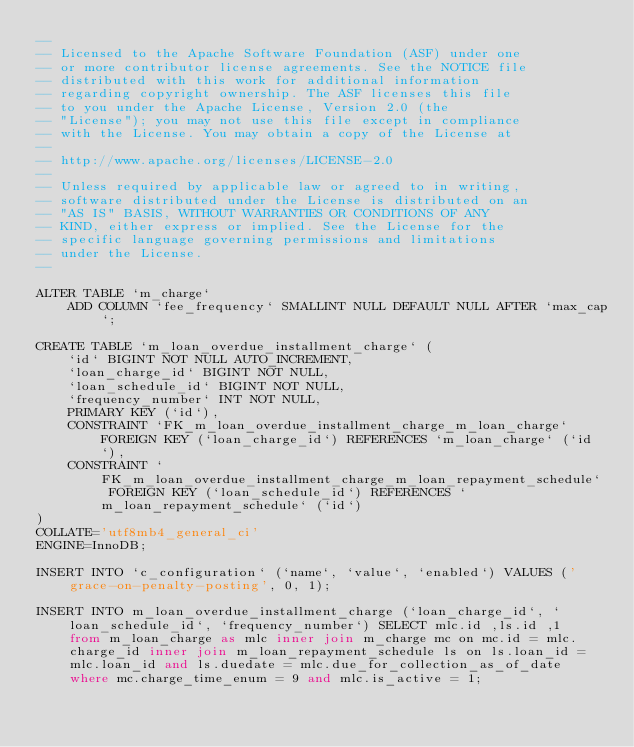<code> <loc_0><loc_0><loc_500><loc_500><_SQL_>--
-- Licensed to the Apache Software Foundation (ASF) under one
-- or more contributor license agreements. See the NOTICE file
-- distributed with this work for additional information
-- regarding copyright ownership. The ASF licenses this file
-- to you under the Apache License, Version 2.0 (the
-- "License"); you may not use this file except in compliance
-- with the License. You may obtain a copy of the License at
--
-- http://www.apache.org/licenses/LICENSE-2.0
--
-- Unless required by applicable law or agreed to in writing,
-- software distributed under the License is distributed on an
-- "AS IS" BASIS, WITHOUT WARRANTIES OR CONDITIONS OF ANY
-- KIND, either express or implied. See the License for the
-- specific language governing permissions and limitations
-- under the License.
--

ALTER TABLE `m_charge`
    ADD COLUMN `fee_frequency` SMALLINT NULL DEFAULT NULL AFTER `max_cap`;

CREATE TABLE `m_loan_overdue_installment_charge` (
    `id` BIGINT NOT NULL AUTO_INCREMENT,
    `loan_charge_id` BIGINT NOT NULL,
    `loan_schedule_id` BIGINT NOT NULL,
    `frequency_number` INT NOT NULL,
    PRIMARY KEY (`id`),
    CONSTRAINT `FK_m_loan_overdue_installment_charge_m_loan_charge` FOREIGN KEY (`loan_charge_id`) REFERENCES `m_loan_charge` (`id`),
    CONSTRAINT `FK_m_loan_overdue_installment_charge_m_loan_repayment_schedule` FOREIGN KEY (`loan_schedule_id`) REFERENCES `m_loan_repayment_schedule` (`id`)
)
COLLATE='utf8mb4_general_ci'
ENGINE=InnoDB;

INSERT INTO `c_configuration` (`name`, `value`, `enabled`) VALUES ('grace-on-penalty-posting', 0, 1);

INSERT INTO m_loan_overdue_installment_charge (`loan_charge_id`, `loan_schedule_id`, `frequency_number`) SELECT mlc.id ,ls.id ,1  from m_loan_charge as mlc inner join m_charge mc on mc.id = mlc.charge_id inner join m_loan_repayment_schedule ls on ls.loan_id = mlc.loan_id and ls.duedate = mlc.due_for_collection_as_of_date where mc.charge_time_enum = 9 and mlc.is_active = 1;
</code> 